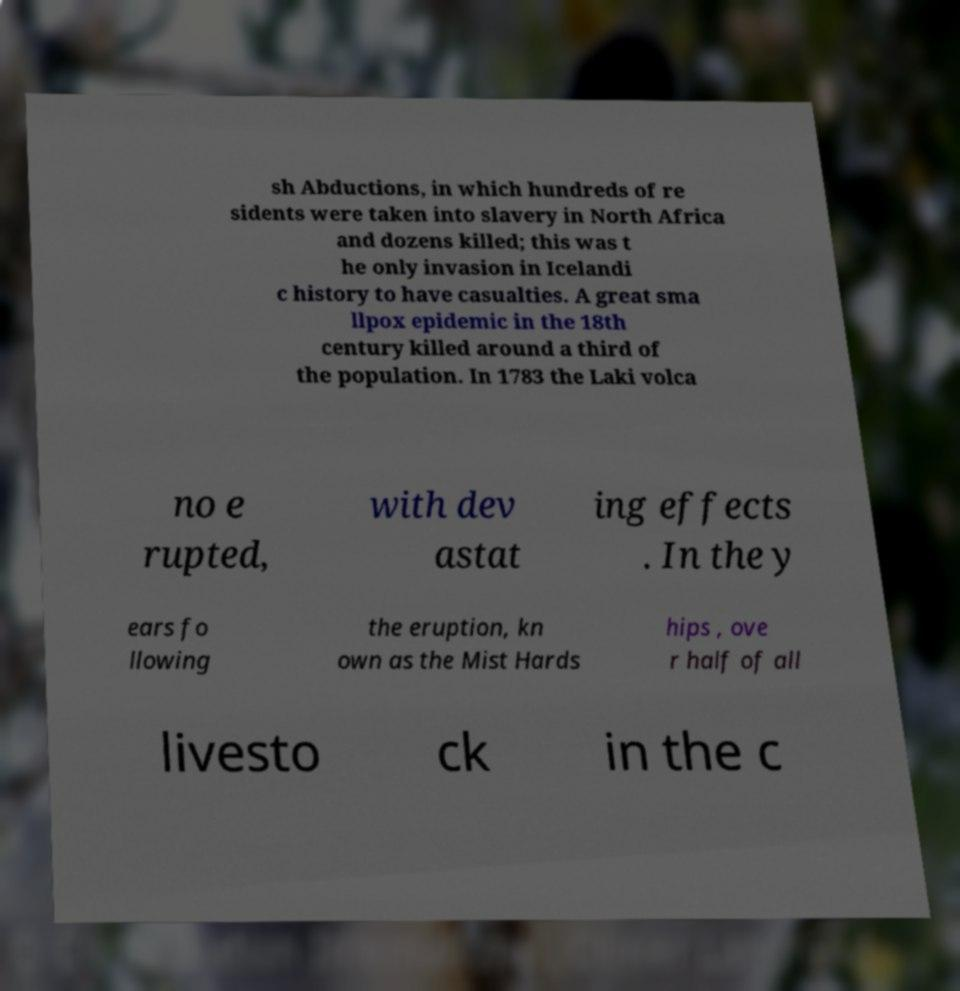Can you read and provide the text displayed in the image?This photo seems to have some interesting text. Can you extract and type it out for me? sh Abductions, in which hundreds of re sidents were taken into slavery in North Africa and dozens killed; this was t he only invasion in Icelandi c history to have casualties. A great sma llpox epidemic in the 18th century killed around a third of the population. In 1783 the Laki volca no e rupted, with dev astat ing effects . In the y ears fo llowing the eruption, kn own as the Mist Hards hips , ove r half of all livesto ck in the c 